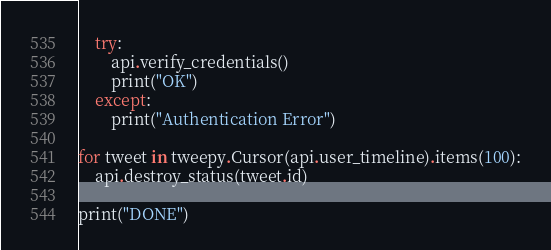Convert code to text. <code><loc_0><loc_0><loc_500><loc_500><_Python_>    try:
        api.verify_credentials()
        print("OK")
    except:
        print("Authentication Error")

for tweet in tweepy.Cursor(api.user_timeline).items(100):
    api.destroy_status(tweet.id)

print("DONE")



</code> 